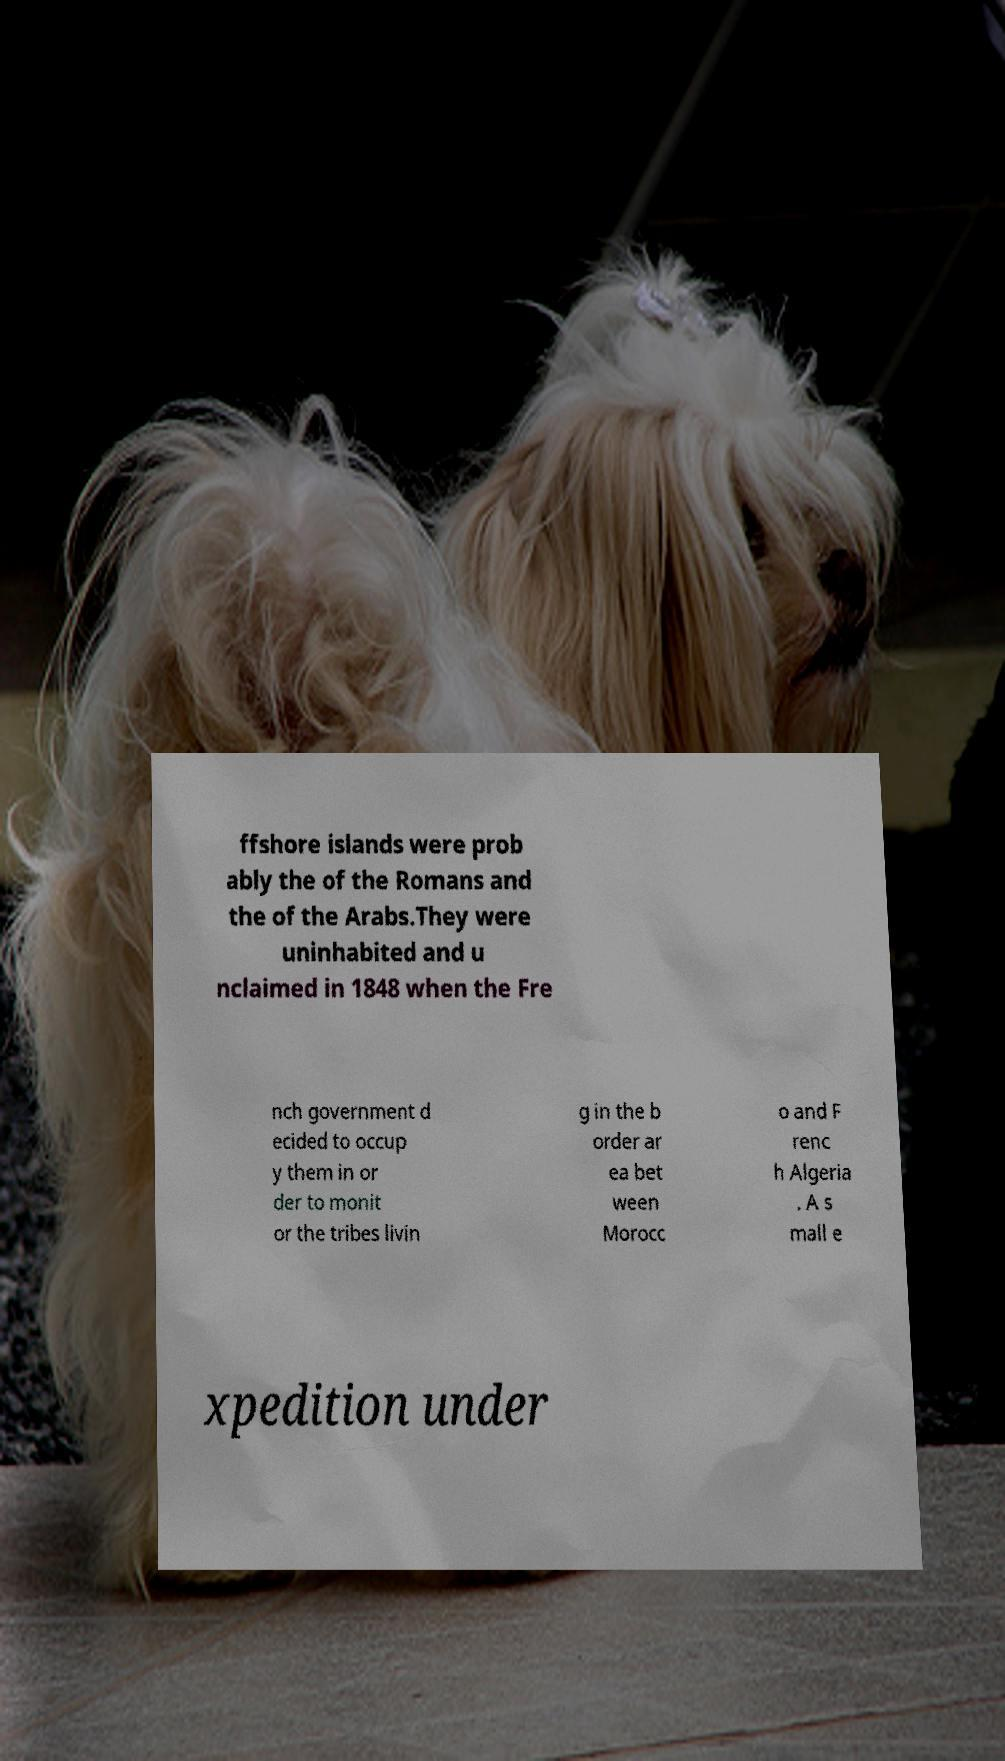What messages or text are displayed in this image? I need them in a readable, typed format. ffshore islands were prob ably the of the Romans and the of the Arabs.They were uninhabited and u nclaimed in 1848 when the Fre nch government d ecided to occup y them in or der to monit or the tribes livin g in the b order ar ea bet ween Morocc o and F renc h Algeria . A s mall e xpedition under 